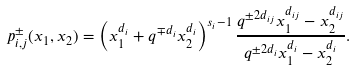<formula> <loc_0><loc_0><loc_500><loc_500>p _ { i , j } ^ { \pm } ( x _ { 1 } , x _ { 2 } ) = \left ( x _ { 1 } ^ { d _ { i } } + q ^ { \mp d _ { i } } x _ { 2 } ^ { d _ { i } } \right ) ^ { s _ { i } - 1 } \frac { q ^ { \pm 2 d _ { i j } } x _ { 1 } ^ { d _ { i j } } - x _ { 2 } ^ { d _ { i j } } } { q ^ { \pm 2 d _ { i } } x _ { 1 } ^ { d _ { i } } - x _ { 2 } ^ { d _ { i } } } .</formula> 